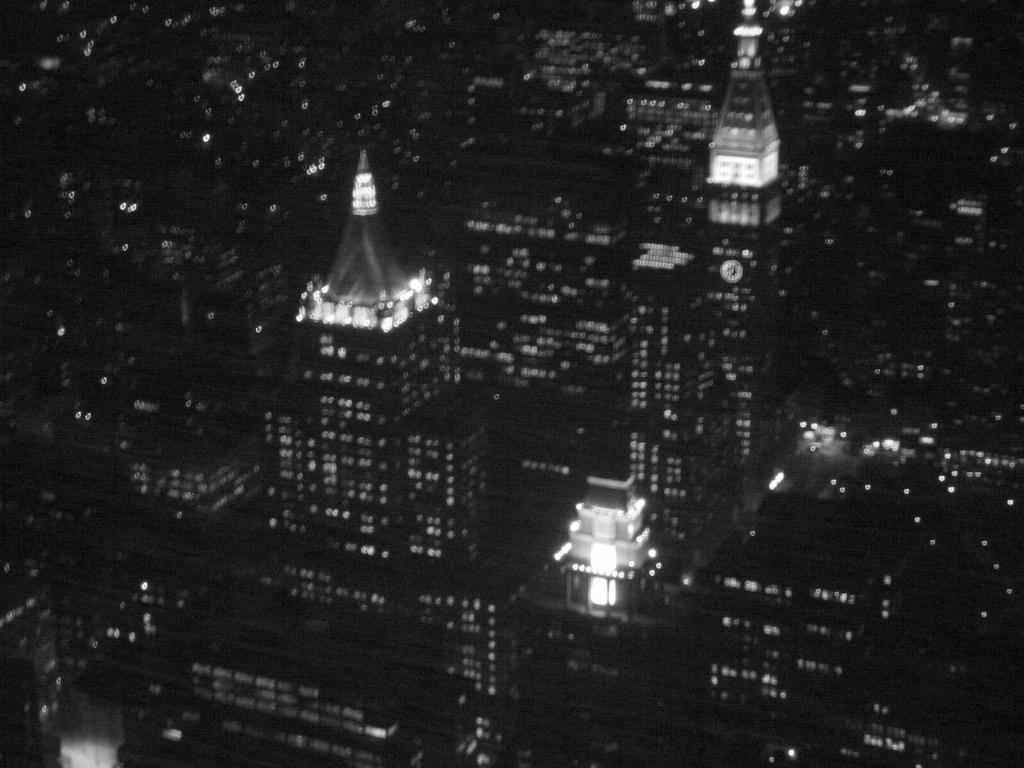What is the color scheme of the image? The image is black and white. How would you describe the overall lighting in the image? The image is dark. What type of structures can be seen in the image? There are buildings in the image. Are there any sources of light visible in the image? Yes, there are lights in the image. What is the value of the slave depicted in the image? There is no slave depicted in the image, as the image does not contain any human figures or references to slavery. 